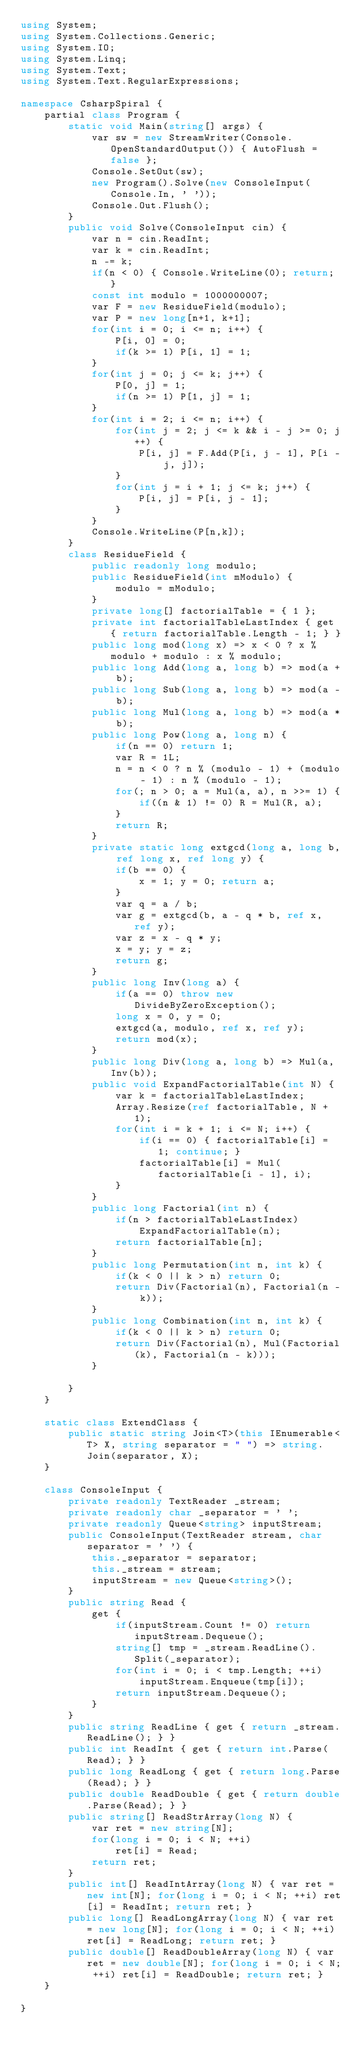Convert code to text. <code><loc_0><loc_0><loc_500><loc_500><_C#_>using System;
using System.Collections.Generic;
using System.IO;
using System.Linq;
using System.Text;
using System.Text.RegularExpressions;

namespace CsharpSpiral {
    partial class Program {
        static void Main(string[] args) {
            var sw = new StreamWriter(Console.OpenStandardOutput()) { AutoFlush = false };
            Console.SetOut(sw);
            new Program().Solve(new ConsoleInput(Console.In, ' '));
            Console.Out.Flush();
        }
        public void Solve(ConsoleInput cin) {
            var n = cin.ReadInt;
            var k = cin.ReadInt;
            n -= k;
            if(n < 0) { Console.WriteLine(0); return; }
            const int modulo = 1000000007;
            var F = new ResidueField(modulo);
            var P = new long[n+1, k+1];
            for(int i = 0; i <= n; i++) {
                P[i, 0] = 0;
                if(k >= 1) P[i, 1] = 1;
            }
            for(int j = 0; j <= k; j++) {
                P[0, j] = 1;
                if(n >= 1) P[1, j] = 1;
            }
            for(int i = 2; i <= n; i++) {
                for(int j = 2; j <= k && i - j >= 0; j++) {
                    P[i, j] = F.Add(P[i, j - 1], P[i - j, j]);
                }
                for(int j = i + 1; j <= k; j++) {
                    P[i, j] = P[i, j - 1];
                }
            }
            Console.WriteLine(P[n,k]);
        }
        class ResidueField {
            public readonly long modulo;
            public ResidueField(int mModulo) {
                modulo = mModulo;
            }
            private long[] factorialTable = { 1 };
            private int factorialTableLastIndex { get { return factorialTable.Length - 1; } }
            public long mod(long x) => x < 0 ? x % modulo + modulo : x % modulo;
            public long Add(long a, long b) => mod(a + b);
            public long Sub(long a, long b) => mod(a - b);
            public long Mul(long a, long b) => mod(a * b);
            public long Pow(long a, long n) {
                if(n == 0) return 1;
                var R = 1L;
                n = n < 0 ? n % (modulo - 1) + (modulo - 1) : n % (modulo - 1);
                for(; n > 0; a = Mul(a, a), n >>= 1) {
                    if((n & 1) != 0) R = Mul(R, a);
                }
                return R;
            }
            private static long extgcd(long a, long b, ref long x, ref long y) {
                if(b == 0) {
                    x = 1; y = 0; return a;
                }
                var q = a / b;
                var g = extgcd(b, a - q * b, ref x, ref y);
                var z = x - q * y;
                x = y; y = z;
                return g;
            }
            public long Inv(long a) {
                if(a == 0) throw new DivideByZeroException();
                long x = 0, y = 0;
                extgcd(a, modulo, ref x, ref y);
                return mod(x);
            }
            public long Div(long a, long b) => Mul(a, Inv(b));
            public void ExpandFactorialTable(int N) {
                var k = factorialTableLastIndex;
                Array.Resize(ref factorialTable, N + 1);
                for(int i = k + 1; i <= N; i++) {
                    if(i == 0) { factorialTable[i] = 1; continue; }
                    factorialTable[i] = Mul(factorialTable[i - 1], i);
                }
            }
            public long Factorial(int n) {
                if(n > factorialTableLastIndex)
                    ExpandFactorialTable(n);
                return factorialTable[n];
            }
            public long Permutation(int n, int k) {
                if(k < 0 || k > n) return 0;
                return Div(Factorial(n), Factorial(n - k));
            }
            public long Combination(int n, int k) {
                if(k < 0 || k > n) return 0;
                return Div(Factorial(n), Mul(Factorial(k), Factorial(n - k)));
            }
            
        }
    }

    static class ExtendClass {
        public static string Join<T>(this IEnumerable<T> X, string separator = " ") => string.Join(separator, X);
    }

    class ConsoleInput {
        private readonly TextReader _stream;
        private readonly char _separator = ' ';
        private readonly Queue<string> inputStream;
        public ConsoleInput(TextReader stream, char separator = ' ') {
            this._separator = separator;
            this._stream = stream;
            inputStream = new Queue<string>();
        }
        public string Read {
            get {
                if(inputStream.Count != 0) return inputStream.Dequeue();
                string[] tmp = _stream.ReadLine().Split(_separator);
                for(int i = 0; i < tmp.Length; ++i)
                    inputStream.Enqueue(tmp[i]);
                return inputStream.Dequeue();
            }
        }
        public string ReadLine { get { return _stream.ReadLine(); } }
        public int ReadInt { get { return int.Parse(Read); } }
        public long ReadLong { get { return long.Parse(Read); } }
        public double ReadDouble { get { return double.Parse(Read); } }
        public string[] ReadStrArray(long N) {
            var ret = new string[N];
            for(long i = 0; i < N; ++i)
                ret[i] = Read;
            return ret;
        }
        public int[] ReadIntArray(long N) { var ret = new int[N]; for(long i = 0; i < N; ++i) ret[i] = ReadInt; return ret; }
        public long[] ReadLongArray(long N) { var ret = new long[N]; for(long i = 0; i < N; ++i) ret[i] = ReadLong; return ret; }
        public double[] ReadDoubleArray(long N) { var ret = new double[N]; for(long i = 0; i < N; ++i) ret[i] = ReadDouble; return ret; }
    }

}

</code> 